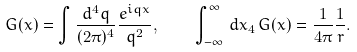Convert formula to latex. <formula><loc_0><loc_0><loc_500><loc_500>G ( x ) = \int \frac { d ^ { 4 } q } { ( 2 \pi ) ^ { 4 } } \frac { e ^ { i q x } } { q ^ { 2 } } , \quad \int _ { - \infty } ^ { \infty } \, d x _ { 4 } \, G ( x ) = \frac { 1 } { 4 \pi } \frac { 1 } { r } .</formula> 